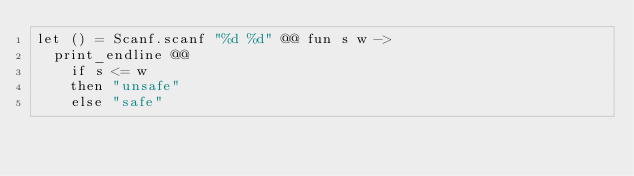Convert code to text. <code><loc_0><loc_0><loc_500><loc_500><_OCaml_>let () = Scanf.scanf "%d %d" @@ fun s w ->
  print_endline @@
    if s <= w
    then "unsafe"
    else "safe"</code> 